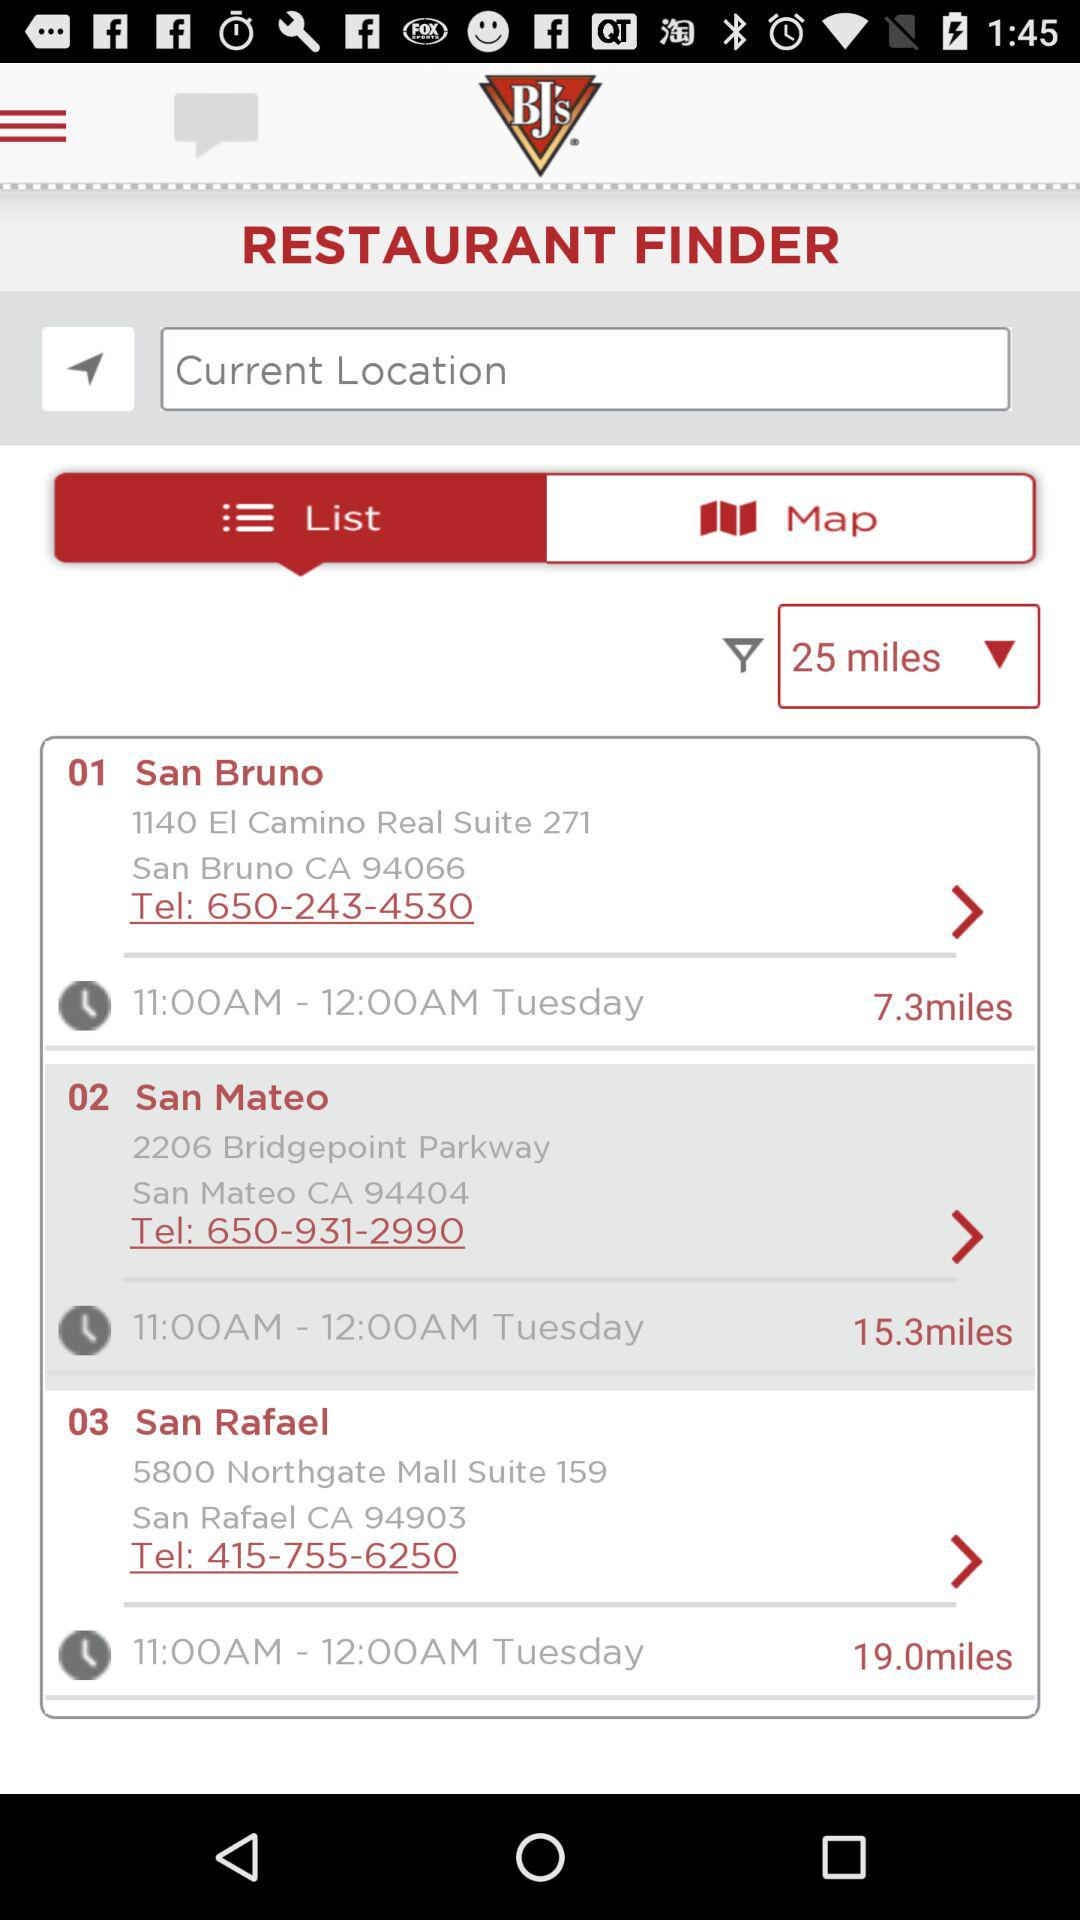What is the selected tab? The selected tab is "List". 